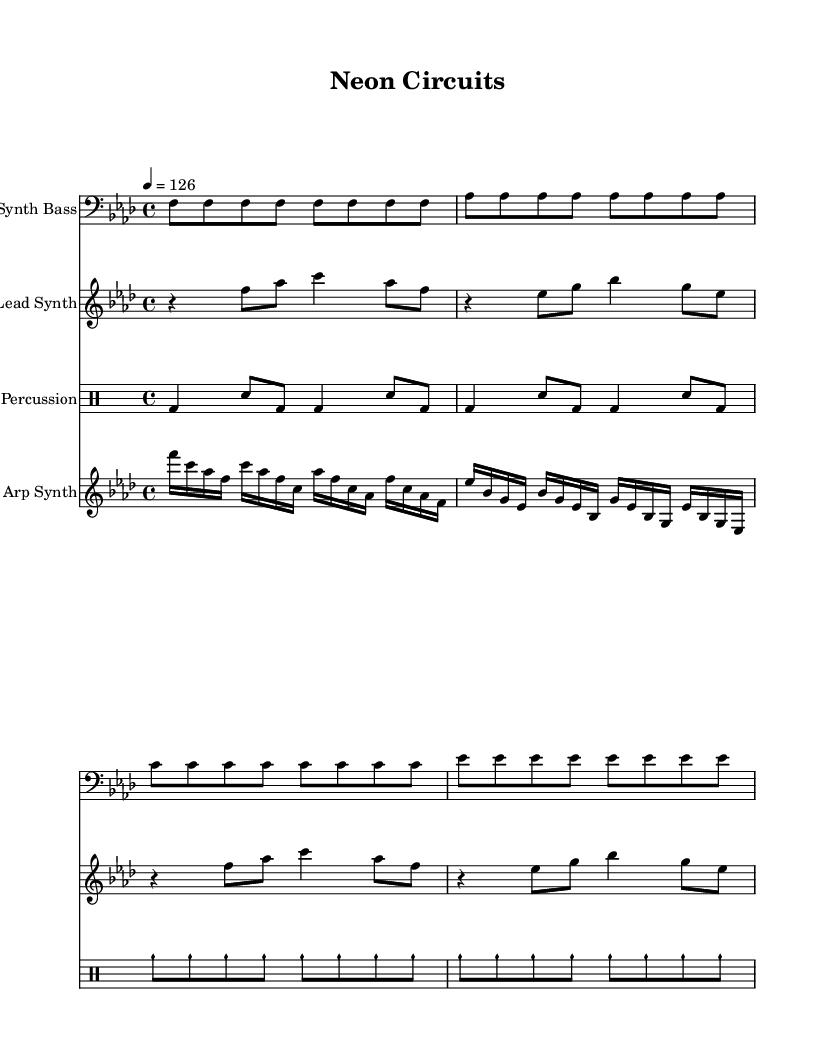What is the key signature of this music? The key signature is indicated by the number of flats shown at the beginning of the staff. Here, there are four flats, which corresponds to F minor.
Answer: F minor What is the time signature of this music? The time signature is determined by the number placed at the beginning of the music. In this case, it is indicated as 4/4, which means there are four beats in a measure and the quarter note gets one beat.
Answer: 4/4 What is the tempo marking of the piece? The tempo is specified with a number indicating the beats per minute (BPM) and is placed at the beginning. Here, it shows "4 = 126," indicating a tempo of 126 BPM.
Answer: 126 How many measures are there in the lead synth part? By counting the measures indicated by the vertical lines (bar lines) on the staff, there are eight measures present in the lead synth part.
Answer: 8 What type of sound is incorporated into the percussion section? The percussion section includes sounds created by traditional drum components, explicitly stating "Industrial Percussion," which signifies the usage of industrial sounds.
Answer: Industrial How many notes are in the arp synth sequence of the first measure? The structure of the arp synth part shows that each note value corresponds to a sixteenth note. In the first measure, there are eight sixteenth notes, leading to a total of eight notes.
Answer: 8 Which instrument section has the most rhythmic variation? By analyzing the different instrument parts, the industrial percussion section has complex, repeated patterns and variations in rhythm, making it stand out in comparison to the others, which have more straightforward patterns.
Answer: Industrial Percussion 